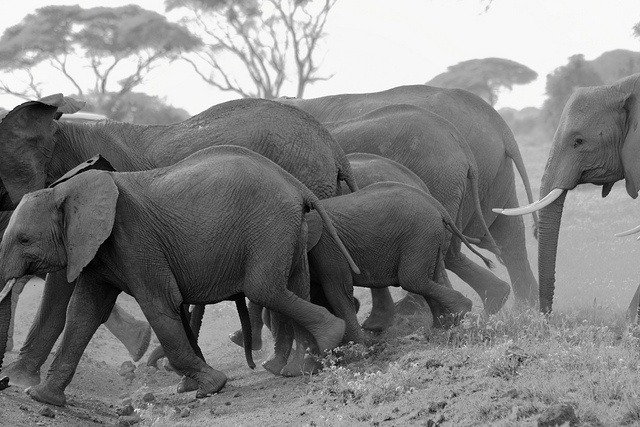Describe the objects in this image and their specific colors. I can see elephant in white, gray, black, and lightgray tones, elephant in white, gray, black, and lightgray tones, elephant in white, gray, black, darkgray, and lightgray tones, elephant in white, gray, darkgray, black, and lightgray tones, and elephant in white, gray, lightgray, and black tones in this image. 